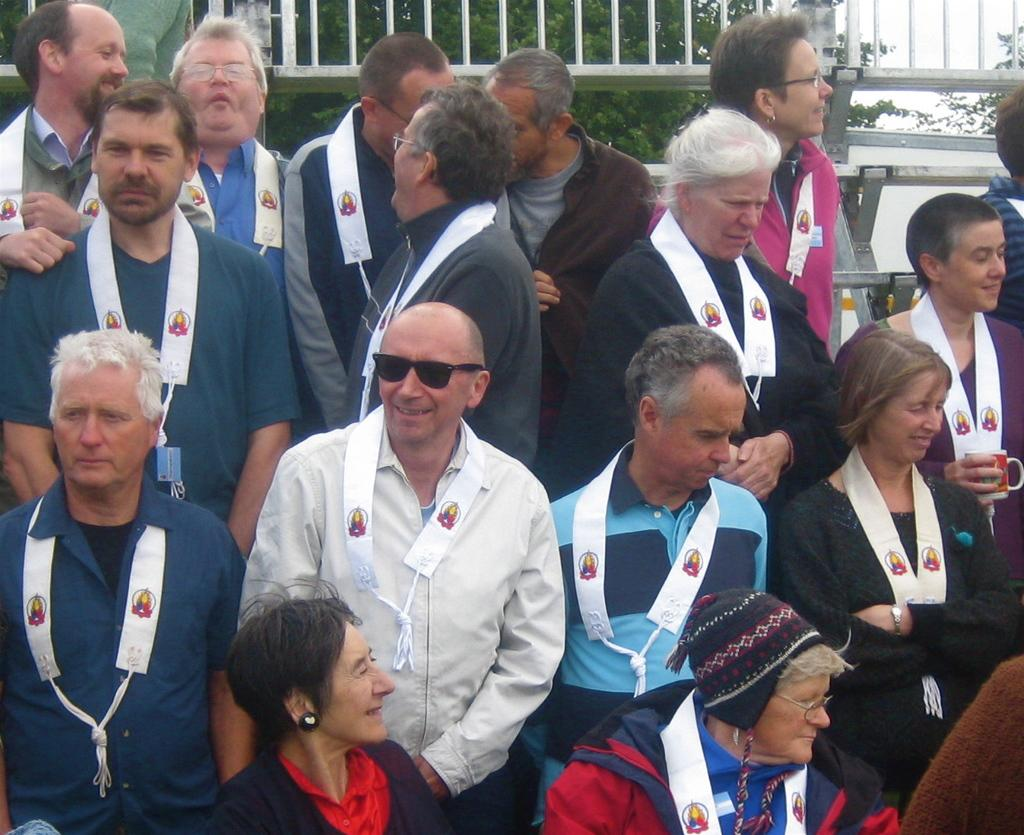How many people are in the image? There are multiple people in the image. What are the people wearing around their necks? The people are wearing white items around their necks. What can be seen in the image besides the people? There is fencing visible in the image. What type of vegetation is visible in the background of the image? Green leaves are present in the background of the image. What is the tendency of the frogs in the image? There are no frogs present in the image, so it is not possible to determine their tendency. 